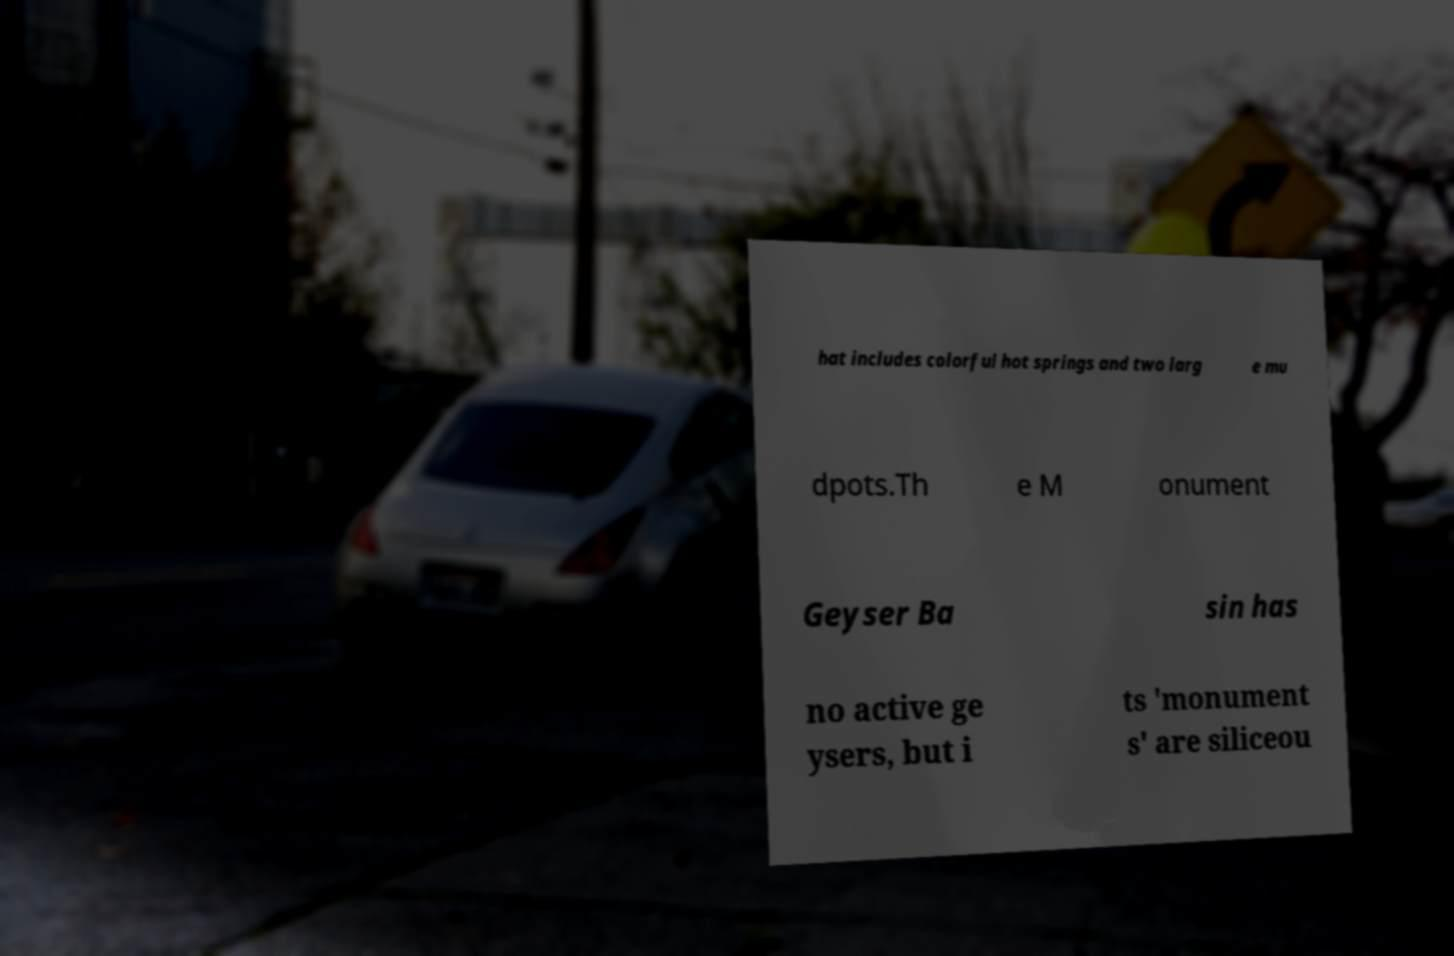I need the written content from this picture converted into text. Can you do that? hat includes colorful hot springs and two larg e mu dpots.Th e M onument Geyser Ba sin has no active ge ysers, but i ts 'monument s' are siliceou 